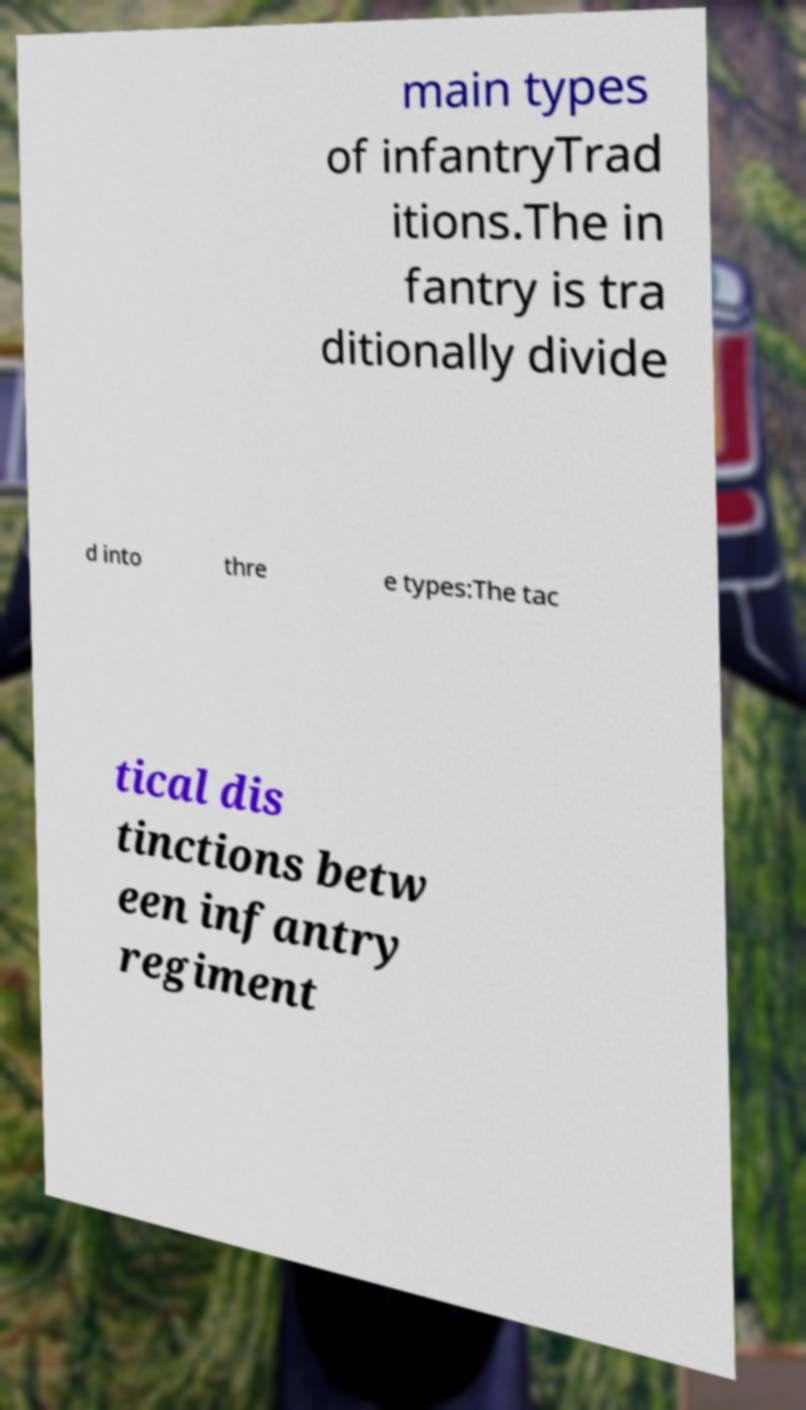Please read and relay the text visible in this image. What does it say? main types of infantryTrad itions.The in fantry is tra ditionally divide d into thre e types:The tac tical dis tinctions betw een infantry regiment 